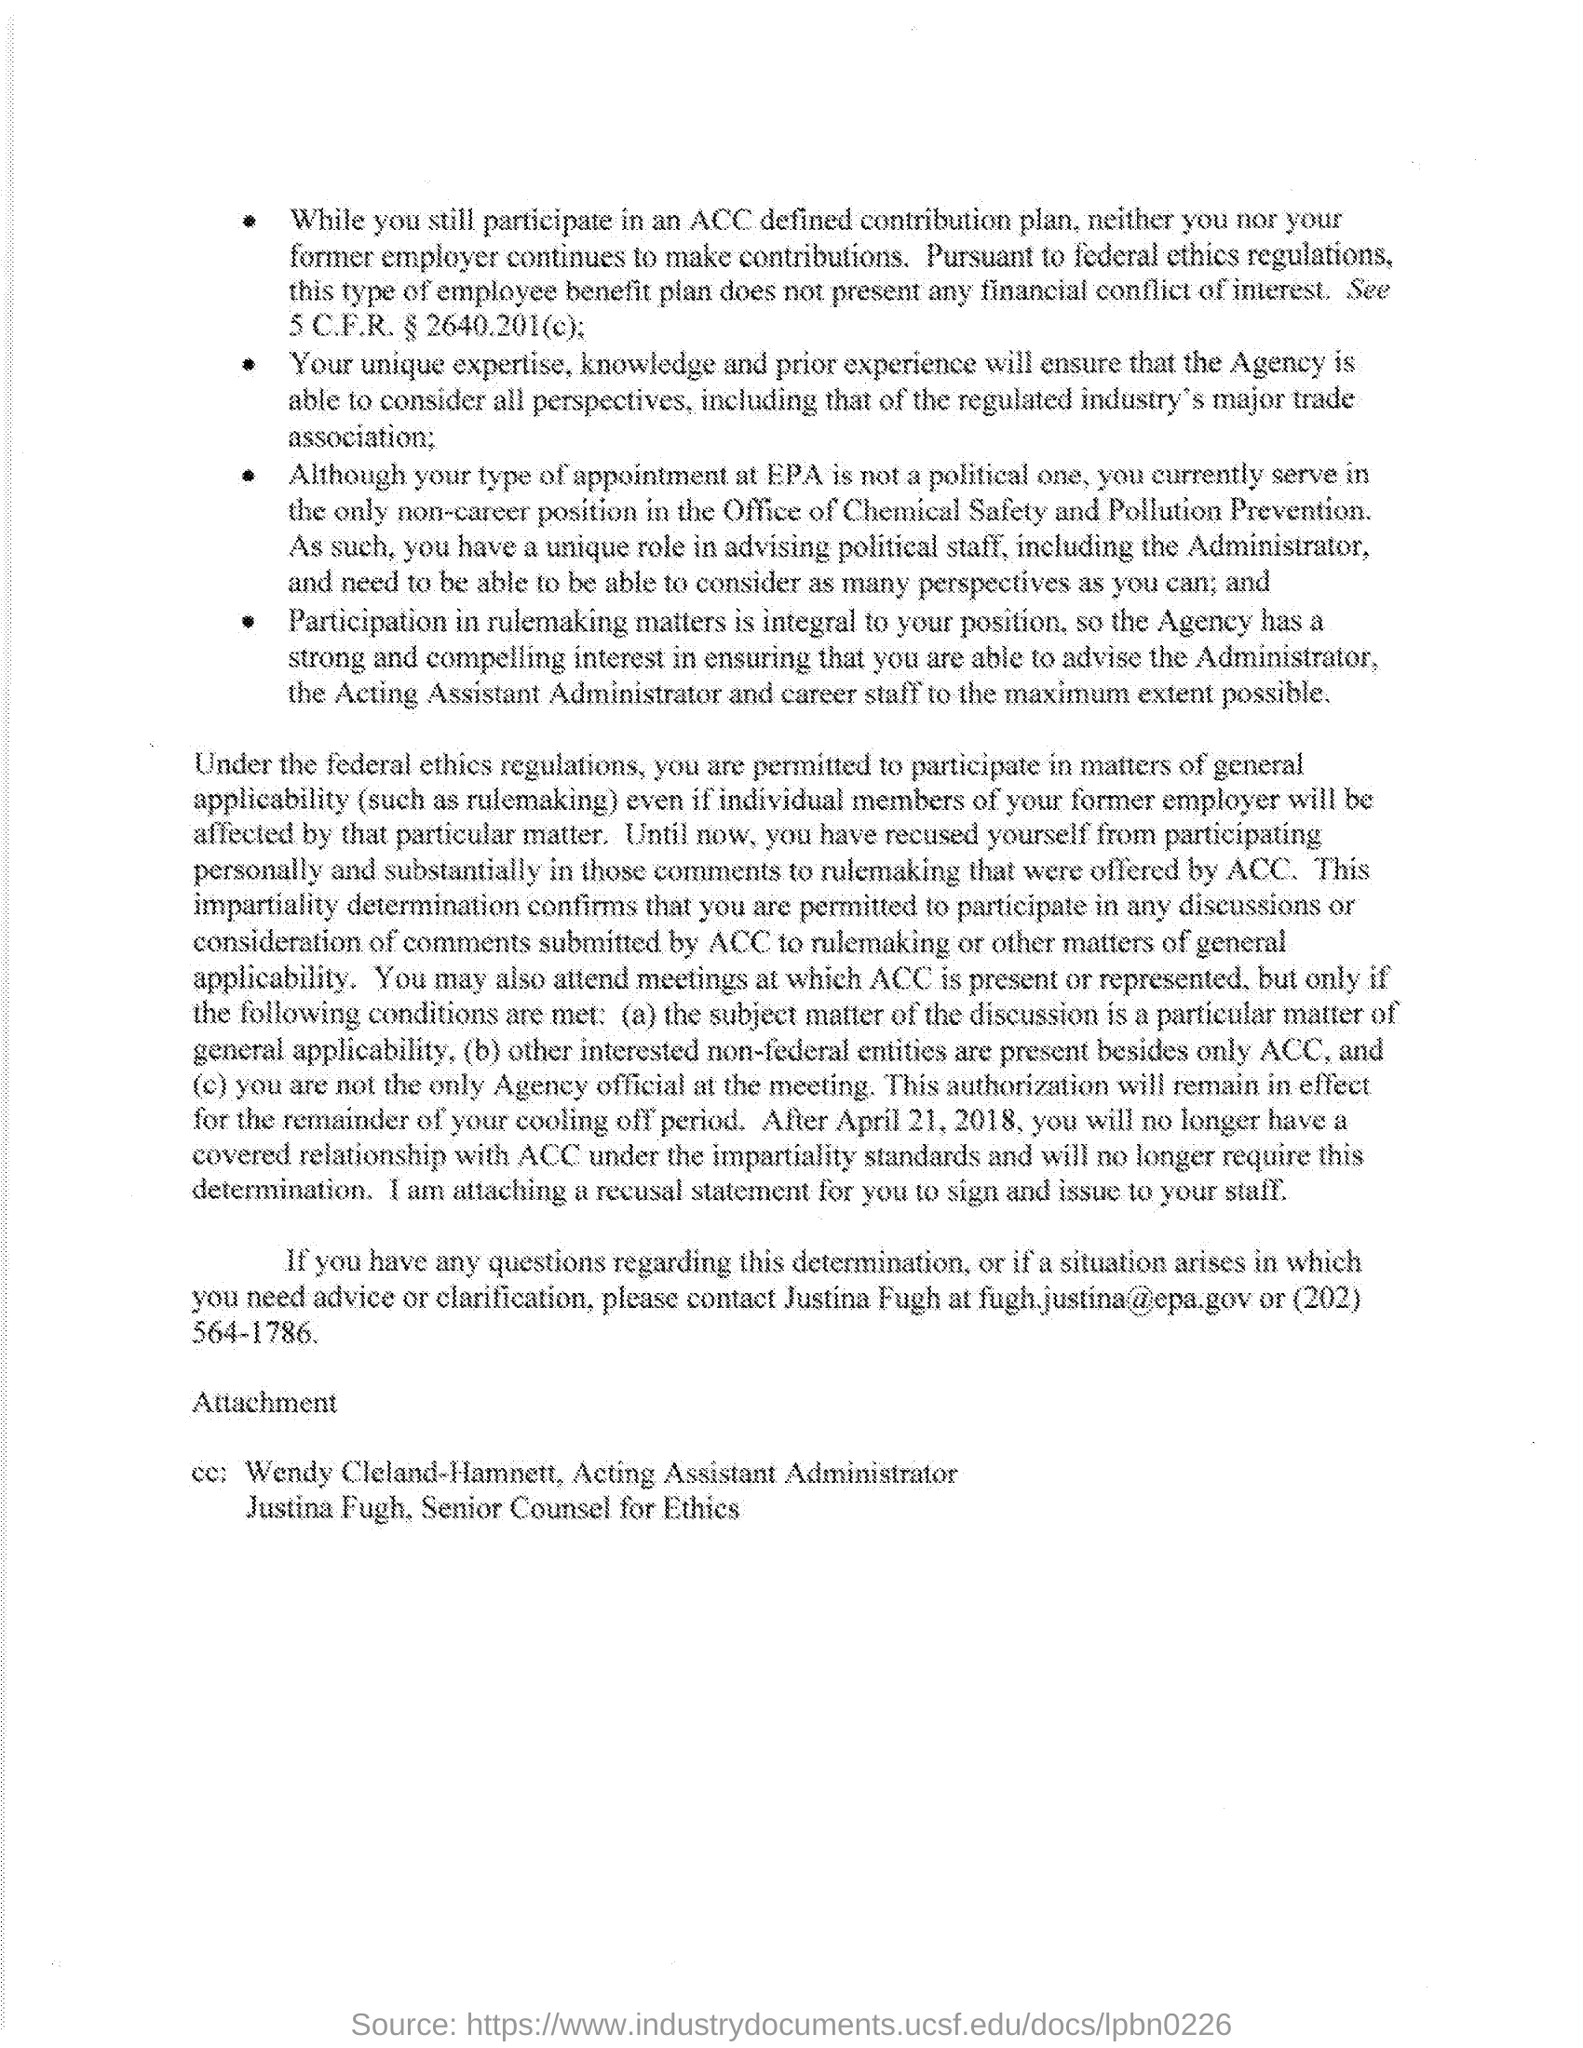Outline some significant characteristics in this image. I have obtained the phone number of Justina Fugh, which is (202) 564-1786. The document indicates that Wendy Cleland-Hamnett is the acting assistant administrator. Justina Fugh holds the designation of Senior Counsel for Ethics. The email address of Justina Fugh is [fugh.justina@epa.gov](mailto:fugh.justina@epa.gov). 